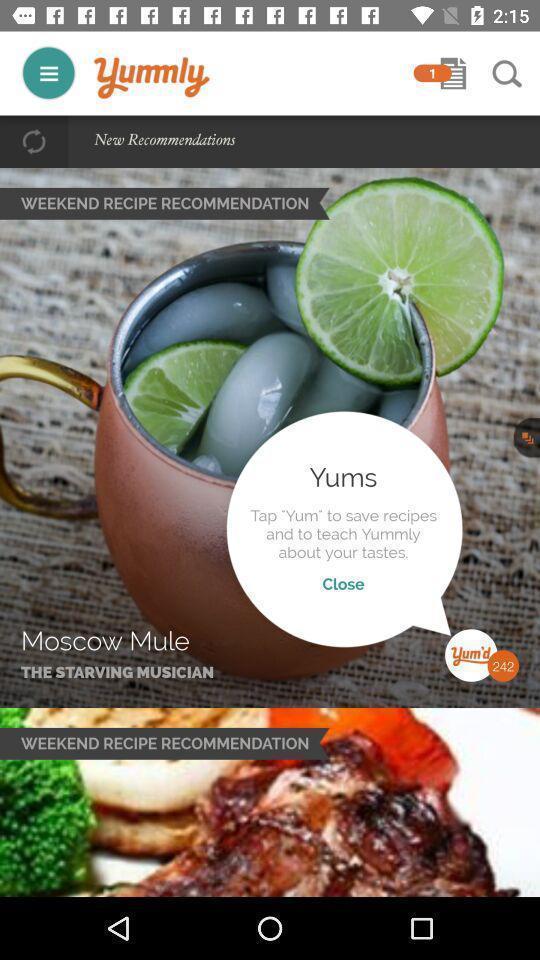Summarize the information in this screenshot. Recipe page displayed of a cooking app. 